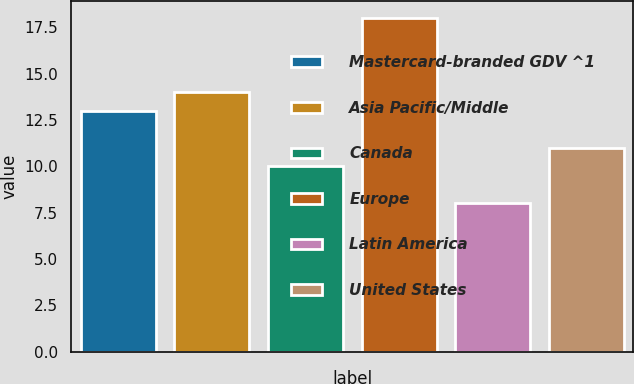<chart> <loc_0><loc_0><loc_500><loc_500><bar_chart><fcel>Mastercard-branded GDV ^1<fcel>Asia Pacific/Middle<fcel>Canada<fcel>Europe<fcel>Latin America<fcel>United States<nl><fcel>13<fcel>14<fcel>10<fcel>18<fcel>8<fcel>11<nl></chart> 